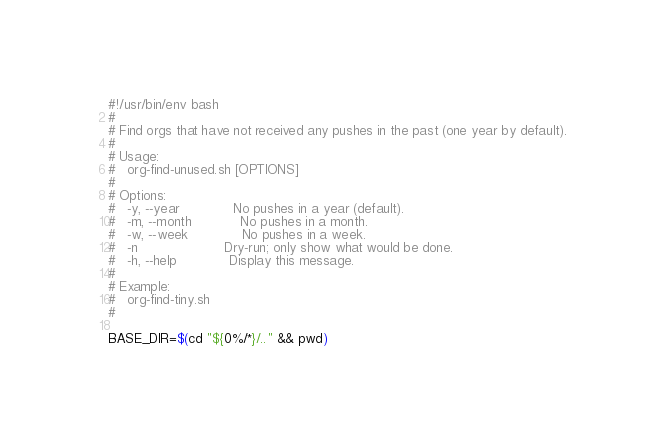Convert code to text. <code><loc_0><loc_0><loc_500><loc_500><_Bash_>#!/usr/bin/env bash
#
# Find orgs that have not received any pushes in the past (one year by default).
#
# Usage:
#   org-find-unused.sh [OPTIONS]
#
# Options:
#   -y, --year             No pushes in a year (default).
#   -m, --month            No pushes in a month.
#   -w, --week             No pushes in a week.
#   -n                     Dry-run; only show what would be done.
#   -h, --help             Display this message.
#
# Example:
#   org-find-tiny.sh
#

BASE_DIR=$(cd "${0%/*}/.." && pwd)</code> 